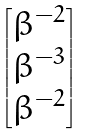<formula> <loc_0><loc_0><loc_500><loc_500>\begin{bmatrix} \beta ^ { - 2 } \\ \beta ^ { - 3 } \\ \beta ^ { - 2 } \\ \end{bmatrix}</formula> 